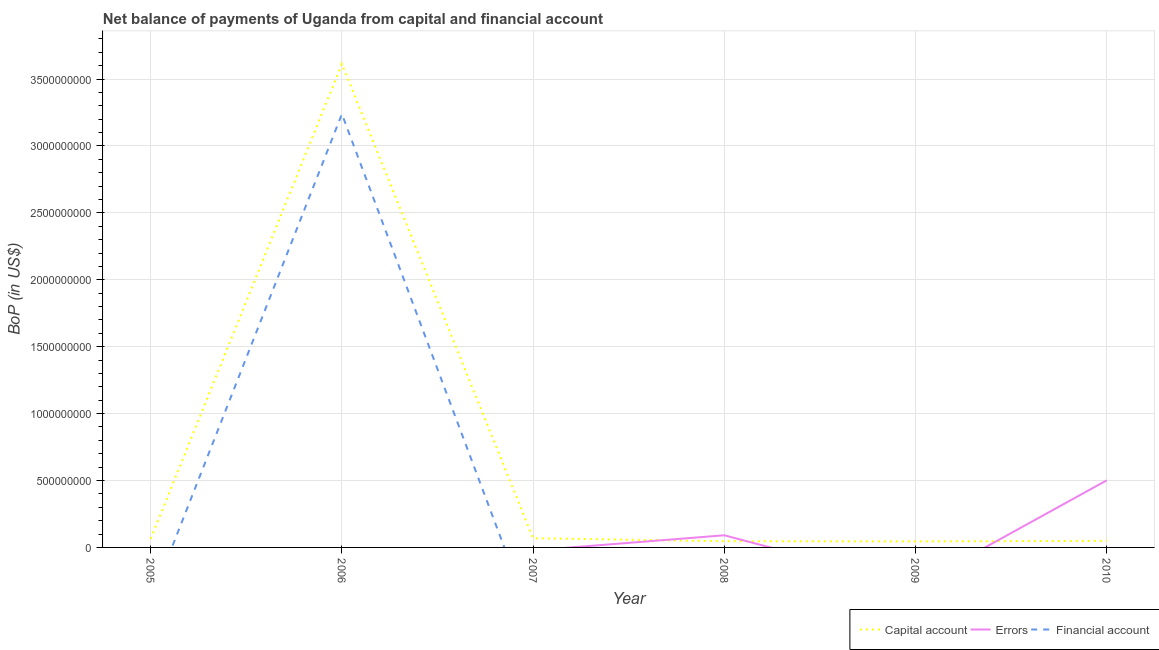Does the line corresponding to amount of financial account intersect with the line corresponding to amount of net capital account?
Offer a terse response. No. Is the number of lines equal to the number of legend labels?
Offer a terse response. No. Across all years, what is the maximum amount of financial account?
Provide a short and direct response. 3.24e+09. In which year was the amount of net capital account maximum?
Provide a succinct answer. 2006. What is the total amount of net capital account in the graph?
Offer a very short reply. 3.89e+09. What is the difference between the amount of net capital account in 2006 and that in 2007?
Provide a succinct answer. 3.54e+09. What is the difference between the amount of errors in 2007 and the amount of net capital account in 2009?
Keep it short and to the point. -4.49e+07. What is the average amount of financial account per year?
Provide a succinct answer. 5.40e+08. In the year 2008, what is the difference between the amount of net capital account and amount of errors?
Offer a terse response. -4.42e+07. In how many years, is the amount of net capital account greater than 300000000 US$?
Ensure brevity in your answer.  1. What is the ratio of the amount of net capital account in 2006 to that in 2010?
Your answer should be compact. 73.64. Is the amount of net capital account in 2007 less than that in 2009?
Ensure brevity in your answer.  No. What is the difference between the highest and the second highest amount of net capital account?
Give a very brief answer. 3.54e+09. What is the difference between the highest and the lowest amount of errors?
Your response must be concise. 5.01e+08. Is the sum of the amount of net capital account in 2007 and 2008 greater than the maximum amount of errors across all years?
Make the answer very short. No. Is it the case that in every year, the sum of the amount of net capital account and amount of errors is greater than the amount of financial account?
Make the answer very short. Yes. Does the amount of net capital account monotonically increase over the years?
Your response must be concise. No. How many lines are there?
Provide a short and direct response. 3. How many years are there in the graph?
Give a very brief answer. 6. What is the difference between two consecutive major ticks on the Y-axis?
Your answer should be very brief. 5.00e+08. Are the values on the major ticks of Y-axis written in scientific E-notation?
Your answer should be very brief. No. Does the graph contain any zero values?
Offer a terse response. Yes. Does the graph contain grids?
Provide a short and direct response. Yes. What is the title of the graph?
Your response must be concise. Net balance of payments of Uganda from capital and financial account. Does "Agricultural raw materials" appear as one of the legend labels in the graph?
Offer a very short reply. No. What is the label or title of the X-axis?
Ensure brevity in your answer.  Year. What is the label or title of the Y-axis?
Your response must be concise. BoP (in US$). What is the BoP (in US$) of Capital account in 2005?
Make the answer very short. 6.43e+07. What is the BoP (in US$) of Financial account in 2005?
Offer a very short reply. 0. What is the BoP (in US$) of Capital account in 2006?
Your answer should be very brief. 3.61e+09. What is the BoP (in US$) of Financial account in 2006?
Offer a terse response. 3.24e+09. What is the BoP (in US$) of Capital account in 2007?
Provide a short and direct response. 6.86e+07. What is the BoP (in US$) in Errors in 2007?
Provide a short and direct response. 0. What is the BoP (in US$) in Capital account in 2008?
Offer a very short reply. 4.65e+07. What is the BoP (in US$) of Errors in 2008?
Offer a terse response. 9.07e+07. What is the BoP (in US$) in Financial account in 2008?
Keep it short and to the point. 0. What is the BoP (in US$) in Capital account in 2009?
Keep it short and to the point. 4.49e+07. What is the BoP (in US$) in Errors in 2009?
Your answer should be very brief. 0. What is the BoP (in US$) in Financial account in 2009?
Ensure brevity in your answer.  0. What is the BoP (in US$) in Capital account in 2010?
Ensure brevity in your answer.  4.91e+07. What is the BoP (in US$) of Errors in 2010?
Make the answer very short. 5.01e+08. What is the BoP (in US$) in Financial account in 2010?
Provide a succinct answer. 0. Across all years, what is the maximum BoP (in US$) of Capital account?
Keep it short and to the point. 3.61e+09. Across all years, what is the maximum BoP (in US$) in Errors?
Make the answer very short. 5.01e+08. Across all years, what is the maximum BoP (in US$) in Financial account?
Provide a succinct answer. 3.24e+09. Across all years, what is the minimum BoP (in US$) of Capital account?
Offer a very short reply. 4.49e+07. What is the total BoP (in US$) of Capital account in the graph?
Provide a succinct answer. 3.89e+09. What is the total BoP (in US$) in Errors in the graph?
Make the answer very short. 5.92e+08. What is the total BoP (in US$) in Financial account in the graph?
Keep it short and to the point. 3.24e+09. What is the difference between the BoP (in US$) of Capital account in 2005 and that in 2006?
Your answer should be compact. -3.55e+09. What is the difference between the BoP (in US$) in Capital account in 2005 and that in 2007?
Make the answer very short. -4.29e+06. What is the difference between the BoP (in US$) in Capital account in 2005 and that in 2008?
Offer a very short reply. 1.78e+07. What is the difference between the BoP (in US$) in Capital account in 2005 and that in 2009?
Give a very brief answer. 1.94e+07. What is the difference between the BoP (in US$) of Capital account in 2005 and that in 2010?
Keep it short and to the point. 1.52e+07. What is the difference between the BoP (in US$) in Capital account in 2006 and that in 2007?
Keep it short and to the point. 3.54e+09. What is the difference between the BoP (in US$) of Capital account in 2006 and that in 2008?
Your response must be concise. 3.57e+09. What is the difference between the BoP (in US$) in Capital account in 2006 and that in 2009?
Ensure brevity in your answer.  3.57e+09. What is the difference between the BoP (in US$) in Capital account in 2006 and that in 2010?
Provide a succinct answer. 3.56e+09. What is the difference between the BoP (in US$) in Capital account in 2007 and that in 2008?
Offer a terse response. 2.21e+07. What is the difference between the BoP (in US$) of Capital account in 2007 and that in 2009?
Your answer should be very brief. 2.37e+07. What is the difference between the BoP (in US$) of Capital account in 2007 and that in 2010?
Your answer should be compact. 1.95e+07. What is the difference between the BoP (in US$) in Capital account in 2008 and that in 2009?
Ensure brevity in your answer.  1.62e+06. What is the difference between the BoP (in US$) in Capital account in 2008 and that in 2010?
Offer a very short reply. -2.56e+06. What is the difference between the BoP (in US$) of Errors in 2008 and that in 2010?
Offer a terse response. -4.11e+08. What is the difference between the BoP (in US$) in Capital account in 2009 and that in 2010?
Make the answer very short. -4.18e+06. What is the difference between the BoP (in US$) in Capital account in 2005 and the BoP (in US$) in Financial account in 2006?
Ensure brevity in your answer.  -3.17e+09. What is the difference between the BoP (in US$) in Capital account in 2005 and the BoP (in US$) in Errors in 2008?
Give a very brief answer. -2.64e+07. What is the difference between the BoP (in US$) of Capital account in 2005 and the BoP (in US$) of Errors in 2010?
Provide a short and direct response. -4.37e+08. What is the difference between the BoP (in US$) of Capital account in 2006 and the BoP (in US$) of Errors in 2008?
Your answer should be very brief. 3.52e+09. What is the difference between the BoP (in US$) in Capital account in 2006 and the BoP (in US$) in Errors in 2010?
Offer a terse response. 3.11e+09. What is the difference between the BoP (in US$) of Capital account in 2007 and the BoP (in US$) of Errors in 2008?
Your answer should be compact. -2.21e+07. What is the difference between the BoP (in US$) of Capital account in 2007 and the BoP (in US$) of Errors in 2010?
Your answer should be compact. -4.33e+08. What is the difference between the BoP (in US$) of Capital account in 2008 and the BoP (in US$) of Errors in 2010?
Give a very brief answer. -4.55e+08. What is the difference between the BoP (in US$) in Capital account in 2009 and the BoP (in US$) in Errors in 2010?
Your answer should be very brief. -4.56e+08. What is the average BoP (in US$) of Capital account per year?
Provide a short and direct response. 6.48e+08. What is the average BoP (in US$) of Errors per year?
Provide a short and direct response. 9.86e+07. What is the average BoP (in US$) in Financial account per year?
Your answer should be compact. 5.40e+08. In the year 2006, what is the difference between the BoP (in US$) of Capital account and BoP (in US$) of Financial account?
Provide a short and direct response. 3.74e+08. In the year 2008, what is the difference between the BoP (in US$) of Capital account and BoP (in US$) of Errors?
Make the answer very short. -4.42e+07. In the year 2010, what is the difference between the BoP (in US$) in Capital account and BoP (in US$) in Errors?
Your answer should be very brief. -4.52e+08. What is the ratio of the BoP (in US$) of Capital account in 2005 to that in 2006?
Ensure brevity in your answer.  0.02. What is the ratio of the BoP (in US$) of Capital account in 2005 to that in 2007?
Make the answer very short. 0.94. What is the ratio of the BoP (in US$) in Capital account in 2005 to that in 2008?
Offer a terse response. 1.38. What is the ratio of the BoP (in US$) in Capital account in 2005 to that in 2009?
Make the answer very short. 1.43. What is the ratio of the BoP (in US$) in Capital account in 2005 to that in 2010?
Offer a terse response. 1.31. What is the ratio of the BoP (in US$) of Capital account in 2006 to that in 2007?
Give a very brief answer. 52.66. What is the ratio of the BoP (in US$) of Capital account in 2006 to that in 2008?
Offer a terse response. 77.69. What is the ratio of the BoP (in US$) of Capital account in 2006 to that in 2009?
Offer a terse response. 80.5. What is the ratio of the BoP (in US$) of Capital account in 2006 to that in 2010?
Offer a very short reply. 73.64. What is the ratio of the BoP (in US$) of Capital account in 2007 to that in 2008?
Your answer should be very brief. 1.48. What is the ratio of the BoP (in US$) in Capital account in 2007 to that in 2009?
Offer a very short reply. 1.53. What is the ratio of the BoP (in US$) of Capital account in 2007 to that in 2010?
Your response must be concise. 1.4. What is the ratio of the BoP (in US$) of Capital account in 2008 to that in 2009?
Provide a succinct answer. 1.04. What is the ratio of the BoP (in US$) in Capital account in 2008 to that in 2010?
Your response must be concise. 0.95. What is the ratio of the BoP (in US$) in Errors in 2008 to that in 2010?
Your answer should be very brief. 0.18. What is the ratio of the BoP (in US$) in Capital account in 2009 to that in 2010?
Provide a short and direct response. 0.91. What is the difference between the highest and the second highest BoP (in US$) of Capital account?
Your response must be concise. 3.54e+09. What is the difference between the highest and the lowest BoP (in US$) of Capital account?
Your answer should be compact. 3.57e+09. What is the difference between the highest and the lowest BoP (in US$) in Errors?
Ensure brevity in your answer.  5.01e+08. What is the difference between the highest and the lowest BoP (in US$) in Financial account?
Make the answer very short. 3.24e+09. 